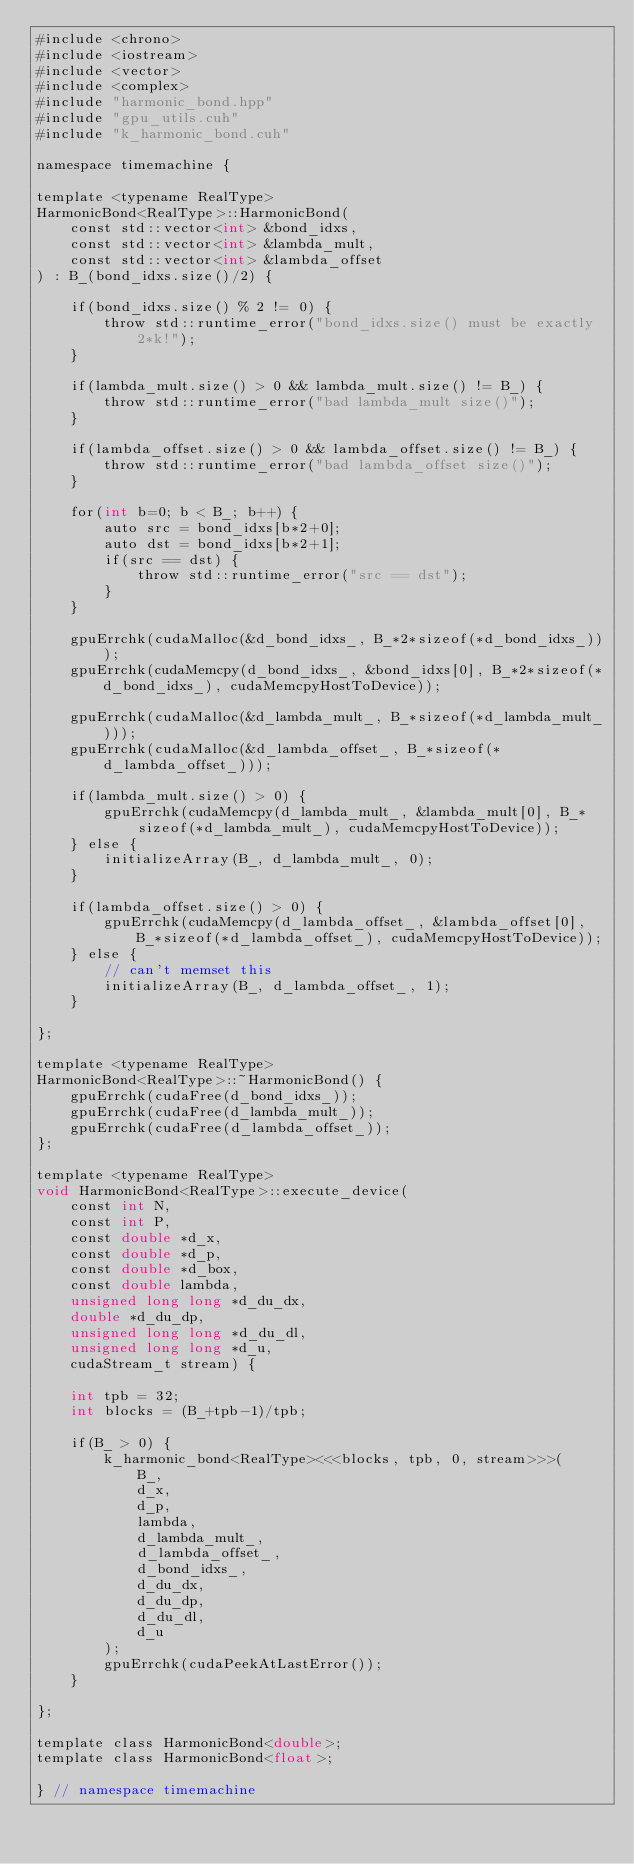Convert code to text. <code><loc_0><loc_0><loc_500><loc_500><_Cuda_>#include <chrono>
#include <iostream>
#include <vector>
#include <complex>
#include "harmonic_bond.hpp"
#include "gpu_utils.cuh"
#include "k_harmonic_bond.cuh"

namespace timemachine {

template <typename RealType>
HarmonicBond<RealType>::HarmonicBond(
    const std::vector<int> &bond_idxs,
    const std::vector<int> &lambda_mult,
    const std::vector<int> &lambda_offset
) : B_(bond_idxs.size()/2) {

    if(bond_idxs.size() % 2 != 0) {
        throw std::runtime_error("bond_idxs.size() must be exactly 2*k!");
    }

    if(lambda_mult.size() > 0 && lambda_mult.size() != B_) {
        throw std::runtime_error("bad lambda_mult size()");
    }

    if(lambda_offset.size() > 0 && lambda_offset.size() != B_) {
        throw std::runtime_error("bad lambda_offset size()");
    }

    for(int b=0; b < B_; b++) {
        auto src = bond_idxs[b*2+0];
        auto dst = bond_idxs[b*2+1];
        if(src == dst) {
            throw std::runtime_error("src == dst");
        }
    }

    gpuErrchk(cudaMalloc(&d_bond_idxs_, B_*2*sizeof(*d_bond_idxs_)));
    gpuErrchk(cudaMemcpy(d_bond_idxs_, &bond_idxs[0], B_*2*sizeof(*d_bond_idxs_), cudaMemcpyHostToDevice));

    gpuErrchk(cudaMalloc(&d_lambda_mult_, B_*sizeof(*d_lambda_mult_)));
    gpuErrchk(cudaMalloc(&d_lambda_offset_, B_*sizeof(*d_lambda_offset_)));

    if(lambda_mult.size() > 0) {
        gpuErrchk(cudaMemcpy(d_lambda_mult_, &lambda_mult[0], B_*sizeof(*d_lambda_mult_), cudaMemcpyHostToDevice));
    } else {
        initializeArray(B_, d_lambda_mult_, 0);
    }

    if(lambda_offset.size() > 0) {
        gpuErrchk(cudaMemcpy(d_lambda_offset_, &lambda_offset[0], B_*sizeof(*d_lambda_offset_), cudaMemcpyHostToDevice));
    } else {
        // can't memset this
        initializeArray(B_, d_lambda_offset_, 1);
    }

};

template <typename RealType>
HarmonicBond<RealType>::~HarmonicBond() {
    gpuErrchk(cudaFree(d_bond_idxs_));
    gpuErrchk(cudaFree(d_lambda_mult_));
    gpuErrchk(cudaFree(d_lambda_offset_));
};

template <typename RealType>
void HarmonicBond<RealType>::execute_device(
    const int N,
    const int P,
    const double *d_x,
    const double *d_p,
    const double *d_box,
    const double lambda,
    unsigned long long *d_du_dx,
    double *d_du_dp,
    unsigned long long *d_du_dl,
    unsigned long long *d_u,
    cudaStream_t stream) {

    int tpb = 32;
    int blocks = (B_+tpb-1)/tpb;

    if(B_ > 0) {
        k_harmonic_bond<RealType><<<blocks, tpb, 0, stream>>>(
            B_,
            d_x,
            d_p,
            lambda,
            d_lambda_mult_,
            d_lambda_offset_,
            d_bond_idxs_,
            d_du_dx,
            d_du_dp,
            d_du_dl,
            d_u
        );
        gpuErrchk(cudaPeekAtLastError());
    }

};

template class HarmonicBond<double>;
template class HarmonicBond<float>;

} // namespace timemachine</code> 